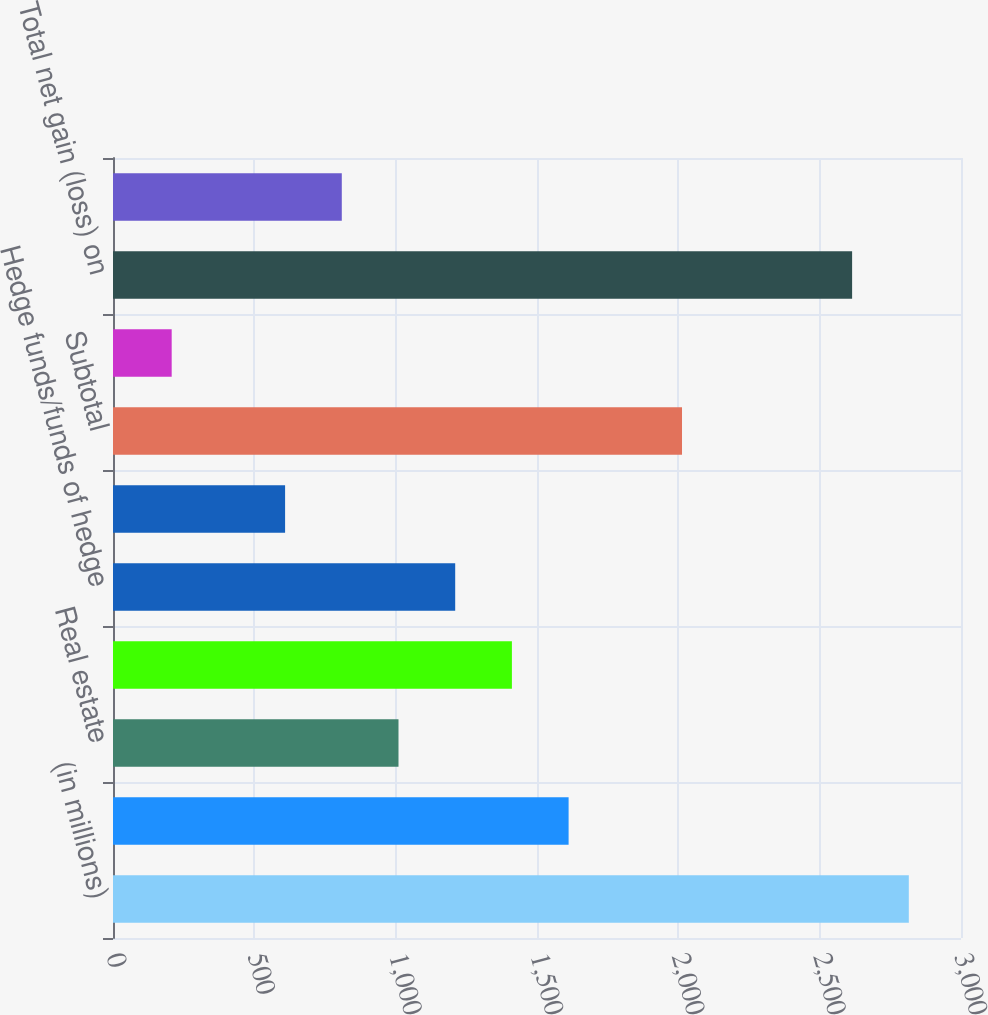Convert chart. <chart><loc_0><loc_0><loc_500><loc_500><bar_chart><fcel>(in millions)<fcel>Private equity<fcel>Real estate<fcel>Distressed credit/mortgage<fcel>Hedge funds/funds of hedge<fcel>Other investments (2)<fcel>Subtotal<fcel>Investments related to<fcel>Total net gain (loss) on<fcel>Interest and dividend income<nl><fcel>2815.4<fcel>1611.8<fcel>1010<fcel>1411.2<fcel>1210.6<fcel>608.8<fcel>2013<fcel>207.6<fcel>2614.8<fcel>809.4<nl></chart> 